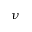<formula> <loc_0><loc_0><loc_500><loc_500>\nu</formula> 